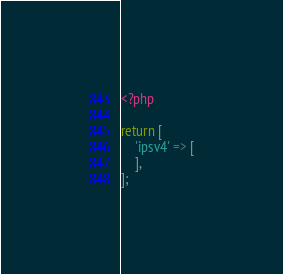Convert code to text. <code><loc_0><loc_0><loc_500><loc_500><_PHP_><?php

return [
    'ipsv4' => [
    ],
];
</code> 